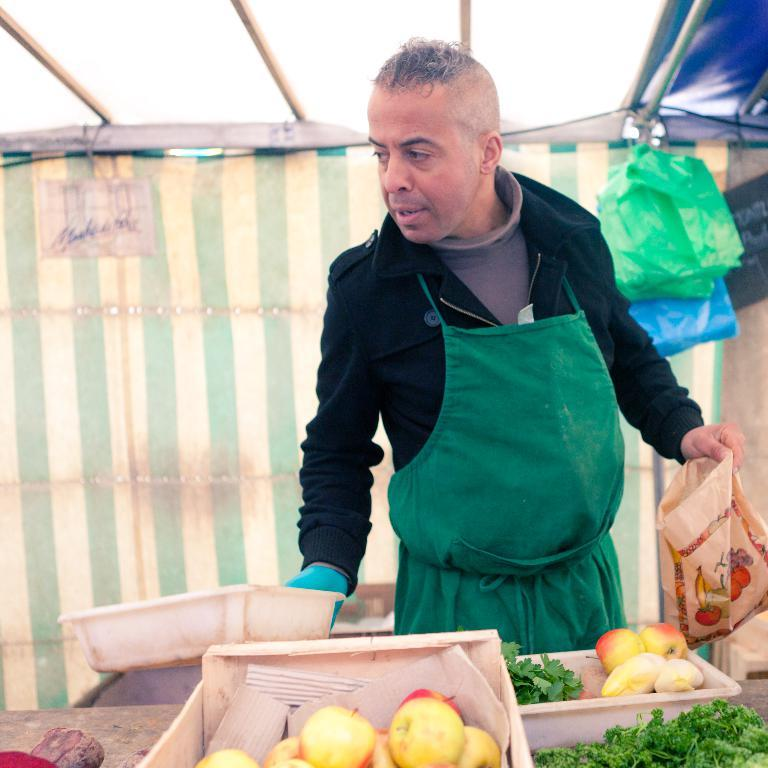What is the main subject of the image? There is a man standing in the image. What objects are present in the image besides the man? There are covers, a table, and trays in the image. What is on the table in the image? The trays on the table contain fruits and leafy vegetables. What type of mine can be seen in the image? There is no mine present in the image; it features a man standing with trays containing fruits and leafy vegetables on a table. What is the zinc content of the fruits in the image? There is no mention of zinc content in the image, as it focuses on the man, trays, and their contents. 